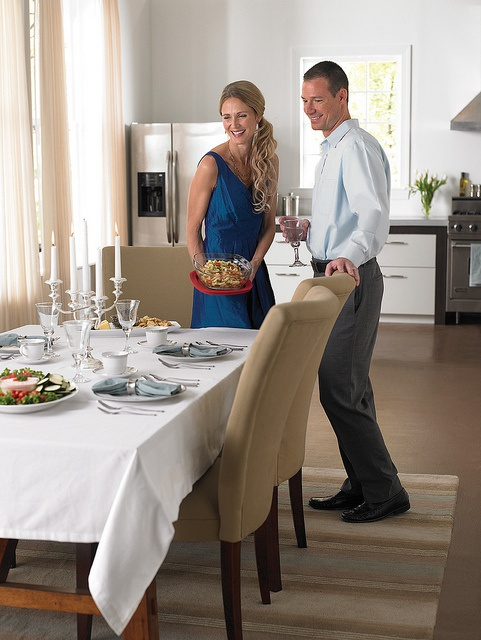Describe the objects in this image and their specific colors. I can see dining table in ivory, lightgray, darkgray, gray, and black tones, people in ivory, black, lightgray, darkgray, and brown tones, chair in ivory, black, and gray tones, people in ivory, black, navy, gray, and blue tones, and refrigerator in ivory, lightgray, darkgray, black, and gray tones in this image. 